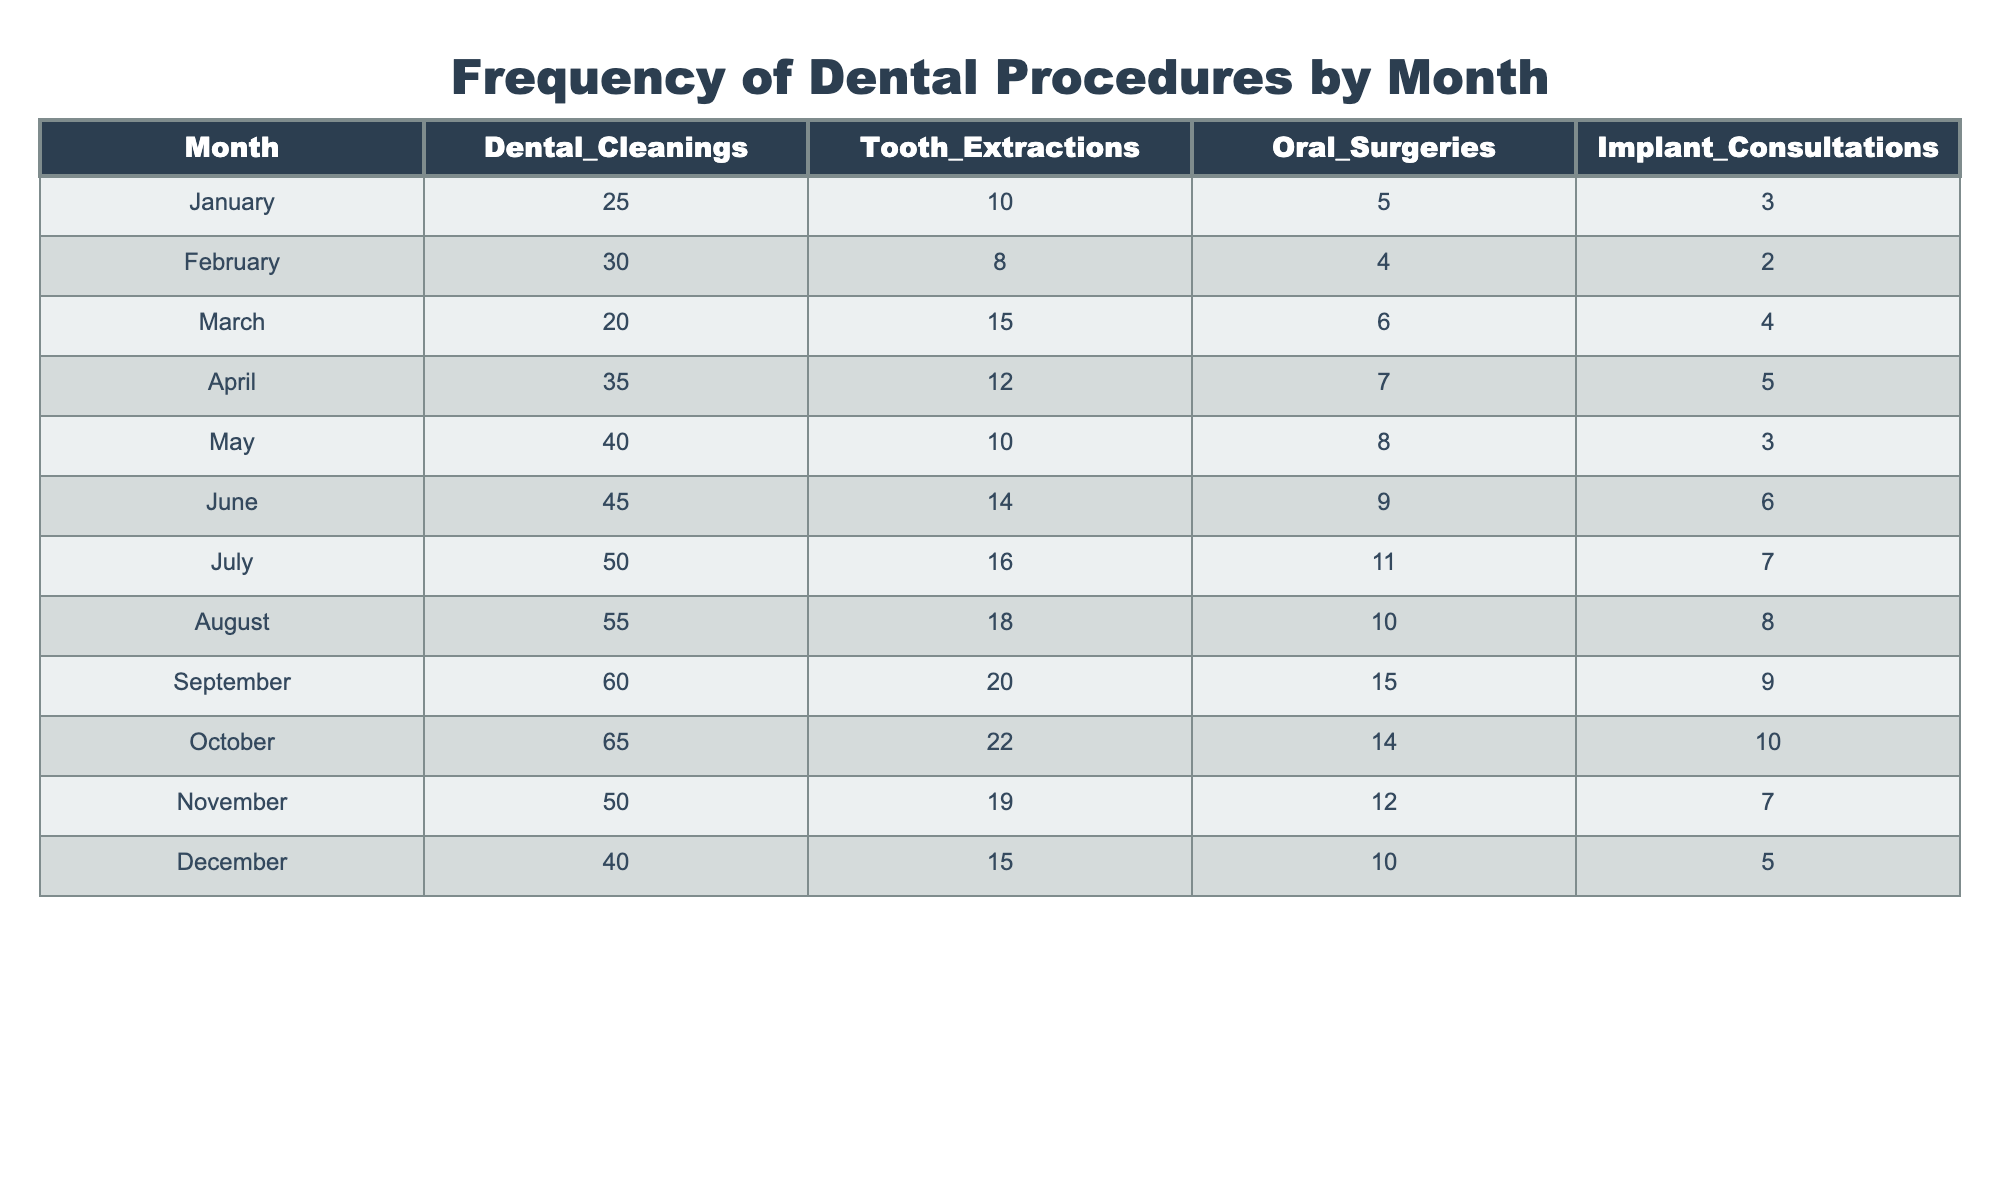What is the total number of dental cleanings performed in June? According to the table, June has 45 dental cleanings recorded.
Answer: 45 Which month had the highest number of tooth extractions? The table indicates that September had the highest number of tooth extractions with a total of 20.
Answer: 20 What is the average number of oral surgeries performed across all months? To find the average, we add all the oral surgeries: 5 + 4 + 6 + 7 + 8 + 9 + 11 + 10 + 15 + 14 + 12 + 10 =  6, so 6/12 = 8.25.
Answer: 8.25 Did the number of implant consultations increase or decrease from January to December? In January, there were 3 implant consultations, and in December, there were 5. Since 5 is greater than 3, it indicates an increase.
Answer: Increase What is the difference between the number of dental cleanings in July and December? From the table, July has 50 dental cleanings, and December has 40. Therefore, the difference is 50 - 40 = 10.
Answer: 10 Which procedure had the least variability in the count throughout the year? To determine variability, we look for the procedure with the smallest range: Dental Cleanings (40), Tooth Extractions (12), Oral Surgeries (10), and Implant Consultations (7). Thus, Implant Consultations had the least variability with a range of 7 (3 to 10).
Answer: Implant Consultations In which month were there fewer than 30 tooth extractions? By checking the table, both January (10) and February (8) had fewer than 30 tooth extractions.
Answer: January and February What is the percentage increase in dental cleanings from January to October? January had 25 dental cleanings, and October had 65. The increase is 65 - 25 = 40. The percentage increase is (40/25) * 100% = 160%.
Answer: 160% In which month was the highest number of oral surgeries performed? From the table, the month with the highest number of oral surgeries is September with 15 surgeries performed.
Answer: September Calculate the total number of dental procedures (including all types) performed in August. In August, there were 55 dental cleanings, 18 tooth extractions, 10 oral surgeries, and 8 implant consultations. Adding them gives 55 + 18 + 10 + 8 = 91 total procedures.
Answer: 91 